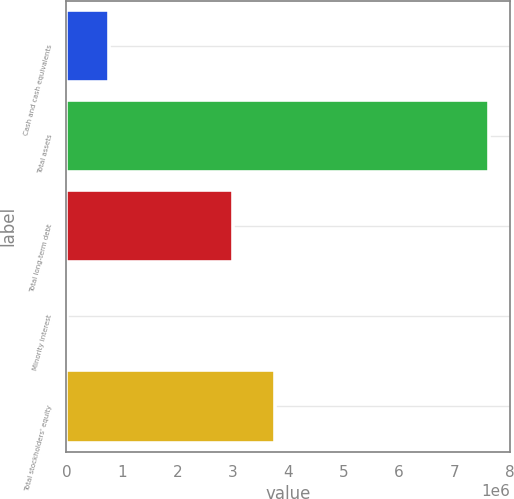<chart> <loc_0><loc_0><loc_500><loc_500><bar_chart><fcel>Cash and cash equivalents<fcel>Total assets<fcel>Total long-term debt<fcel>Minority interest<fcel>Total stockholders' equity<nl><fcel>774729<fcel>7.63056e+06<fcel>3.0095e+06<fcel>12970<fcel>3.77126e+06<nl></chart> 